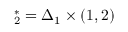Convert formula to latex. <formula><loc_0><loc_0><loc_500><loc_500>\mathbf \Delta _ { 2 } ^ { * } = \Delta _ { 1 } \times ( 1 , 2 )</formula> 